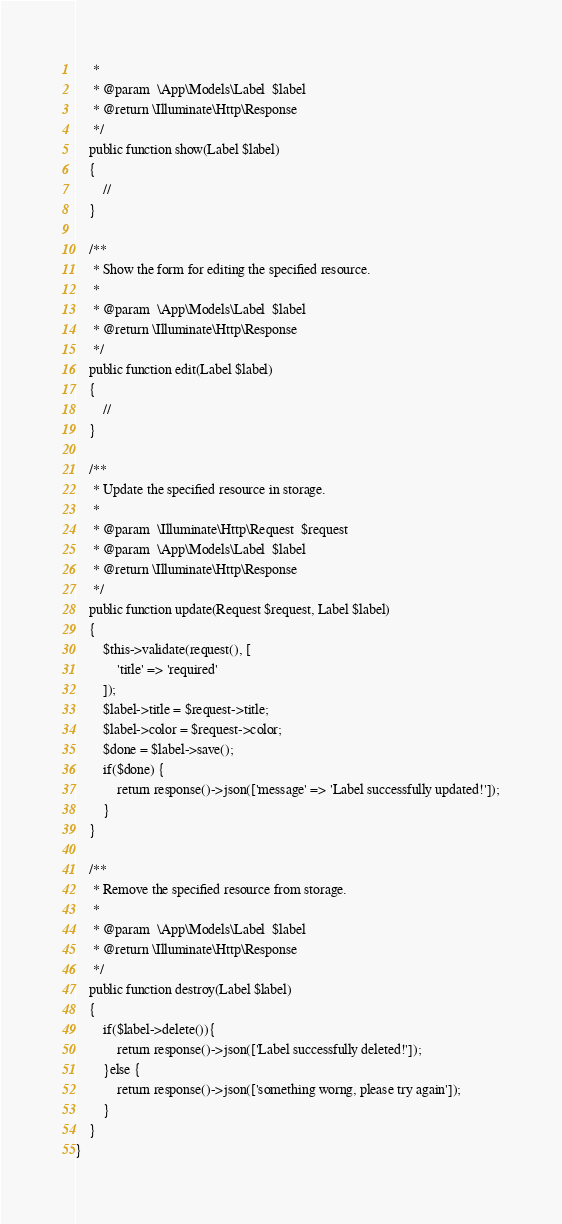Convert code to text. <code><loc_0><loc_0><loc_500><loc_500><_PHP_>     *
     * @param  \App\Models\Label  $label
     * @return \Illuminate\Http\Response
     */
    public function show(Label $label)
    {
        //
    }

    /**
     * Show the form for editing the specified resource.
     *
     * @param  \App\Models\Label  $label
     * @return \Illuminate\Http\Response
     */
    public function edit(Label $label)
    {
        //
    }

    /**
     * Update the specified resource in storage.
     *
     * @param  \Illuminate\Http\Request  $request
     * @param  \App\Models\Label  $label
     * @return \Illuminate\Http\Response
     */
    public function update(Request $request, Label $label)
    {
        $this->validate(request(), [
            'title' => 'required'
        ]);
        $label->title = $request->title;
        $label->color = $request->color;
        $done = $label->save();
        if($done) {
            return response()->json(['message' => 'Label successfully updated!']);
        }
    }

    /**
     * Remove the specified resource from storage.
     *
     * @param  \App\Models\Label  $label
     * @return \Illuminate\Http\Response
     */
    public function destroy(Label $label)
    {
        if($label->delete()){
            return response()->json(['Label successfully deleted!']);
        }else {
            return response()->json(['something worng, please try again']);
        }
    }
}
</code> 